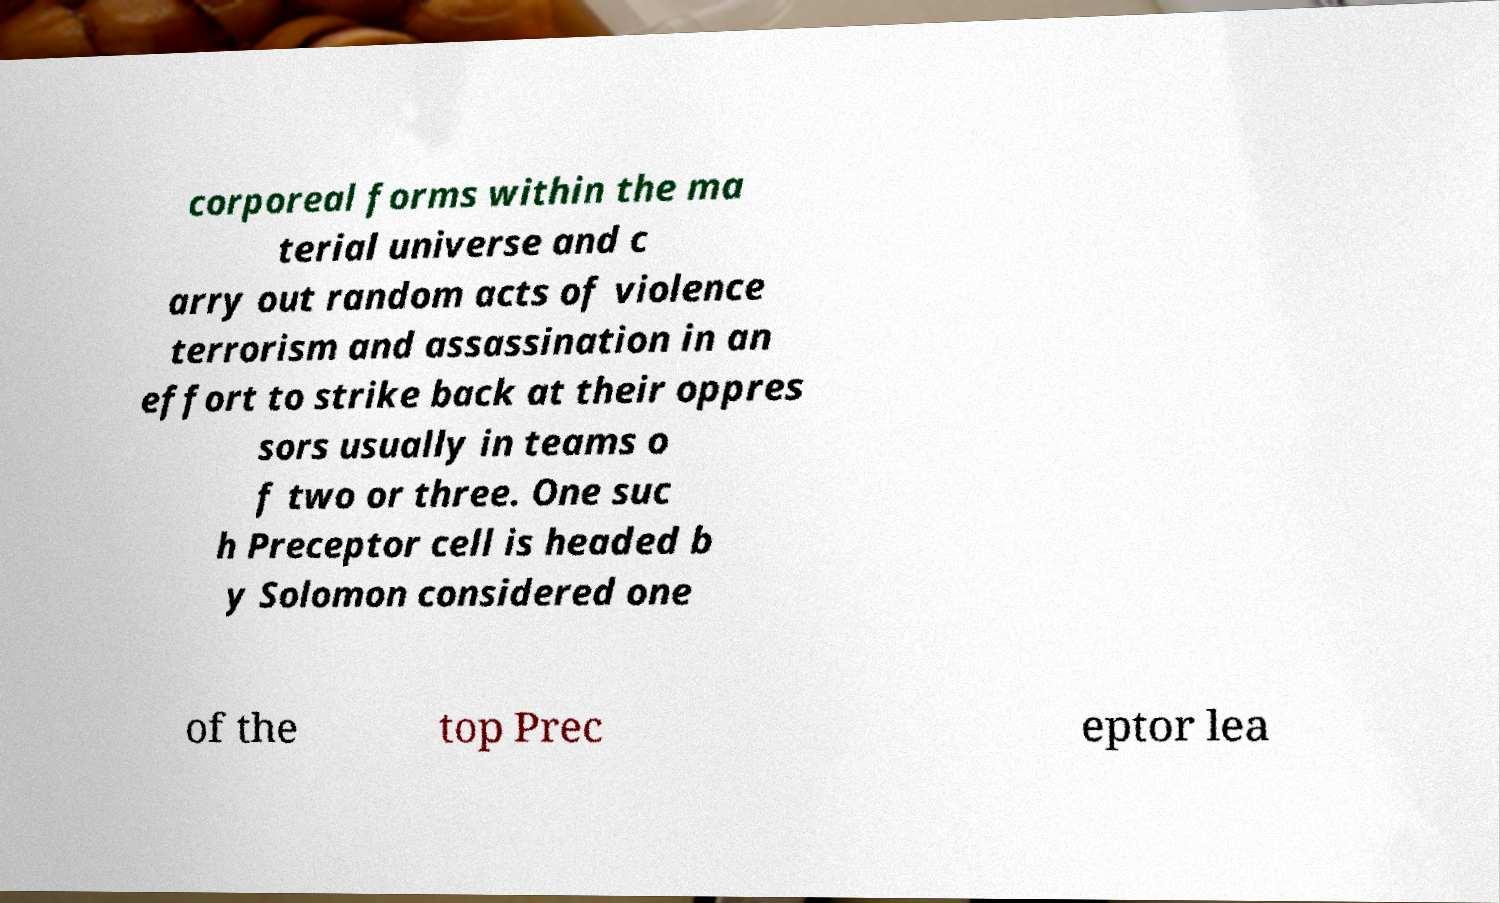I need the written content from this picture converted into text. Can you do that? corporeal forms within the ma terial universe and c arry out random acts of violence terrorism and assassination in an effort to strike back at their oppres sors usually in teams o f two or three. One suc h Preceptor cell is headed b y Solomon considered one of the top Prec eptor lea 